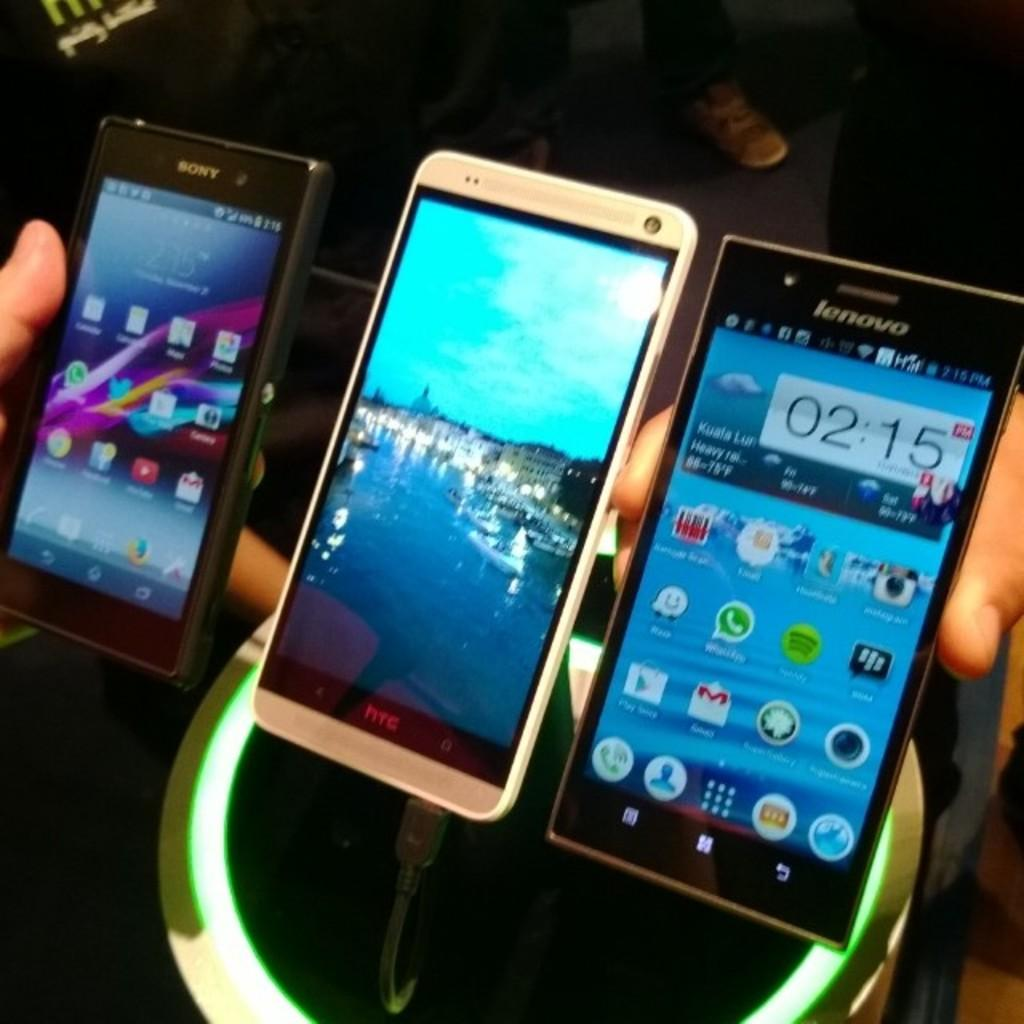<image>
Summarize the visual content of the image. A row of cell phones that say Sony, HTC, and Lenovo. 